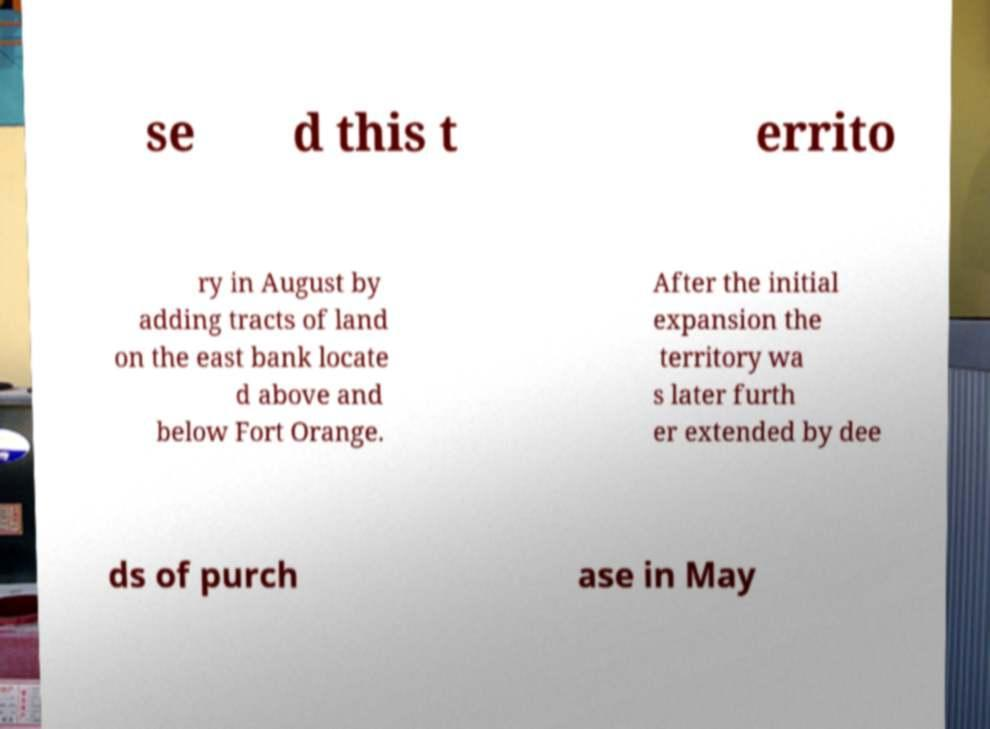For documentation purposes, I need the text within this image transcribed. Could you provide that? se d this t errito ry in August by adding tracts of land on the east bank locate d above and below Fort Orange. After the initial expansion the territory wa s later furth er extended by dee ds of purch ase in May 